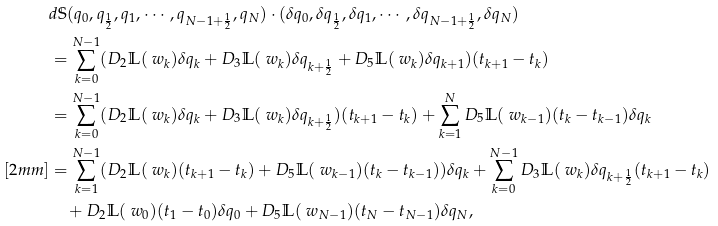<formula> <loc_0><loc_0><loc_500><loc_500>& d \mathbb { S } ( q _ { 0 } , q _ { \frac { 1 } { 2 } } , q _ { 1 } , \cdots , q _ { N - 1 + \frac { 1 } { 2 } } , q _ { N } ) \cdot ( \delta q _ { 0 } , \delta q _ { \frac { 1 } { 2 } } , \delta q _ { 1 } , \cdots , \delta q _ { N - 1 + \frac { 1 } { 2 } } , \delta q _ { N } ) \\ & = \sum _ { k = 0 } ^ { N - 1 } ( D _ { 2 } \mathbb { L } ( \ w _ { k } ) \delta q _ { k } + D _ { 3 } \mathbb { L } ( \ w _ { k } ) \delta q _ { k + \frac { 1 } { 2 } } + D _ { 5 } \mathbb { L } ( \ w _ { k } ) \delta q _ { k + 1 } ) ( t _ { k + 1 } - t _ { k } ) \\ & = \sum _ { k = 0 } ^ { N - 1 } ( D _ { 2 } \mathbb { L } ( \ w _ { k } ) \delta q _ { k } + D _ { 3 } \mathbb { L } ( \ w _ { k } ) \delta q _ { k + \frac { 1 } { 2 } } ) ( t _ { k + 1 } - t _ { k } ) + \sum _ { k = 1 } ^ { N } D _ { 5 } \mathbb { L } ( \ w _ { k - 1 } ) ( t _ { k } - t _ { k - 1 } ) \delta q _ { k } \\ [ 2 m m ] & = \sum _ { k = 1 } ^ { N - 1 } ( D _ { 2 } \mathbb { L } ( \ w _ { k } ) ( t _ { k + 1 } - t _ { k } ) + D _ { 5 } \mathbb { L } ( \ w _ { k - 1 } ) ( t _ { k } - t _ { k - 1 } ) ) \delta q _ { k } + \sum _ { k = 0 } ^ { N - 1 } D _ { 3 } \mathbb { L } ( \ w _ { k } ) \delta q _ { k + \frac { 1 } { 2 } } ( t _ { k + 1 } - t _ { k } ) \\ & \quad + D _ { 2 } \mathbb { L } ( \ w _ { 0 } ) ( t _ { 1 } - t _ { 0 } ) \delta q _ { 0 } + D _ { 5 } \mathbb { L } ( \ w _ { N - 1 } ) ( t _ { N } - t _ { N - 1 } ) \delta q _ { N } ,</formula> 